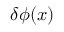<formula> <loc_0><loc_0><loc_500><loc_500>\delta \phi ( { x } )</formula> 